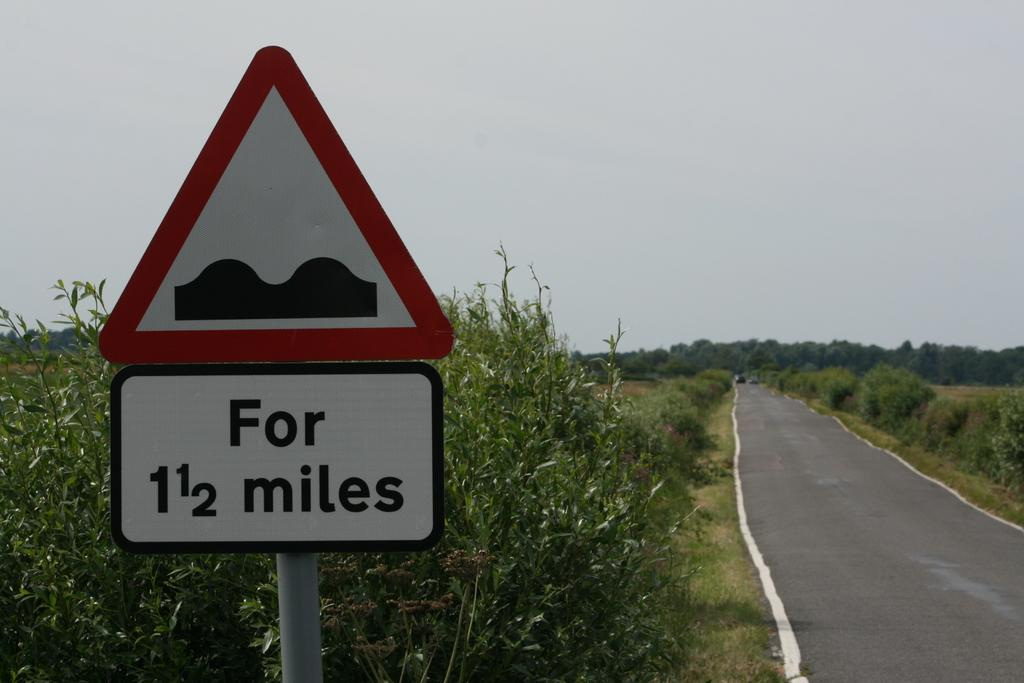<image>
Summarize the visual content of the image. A road side reads " For 1 1/2 miles"next to an empty country road 